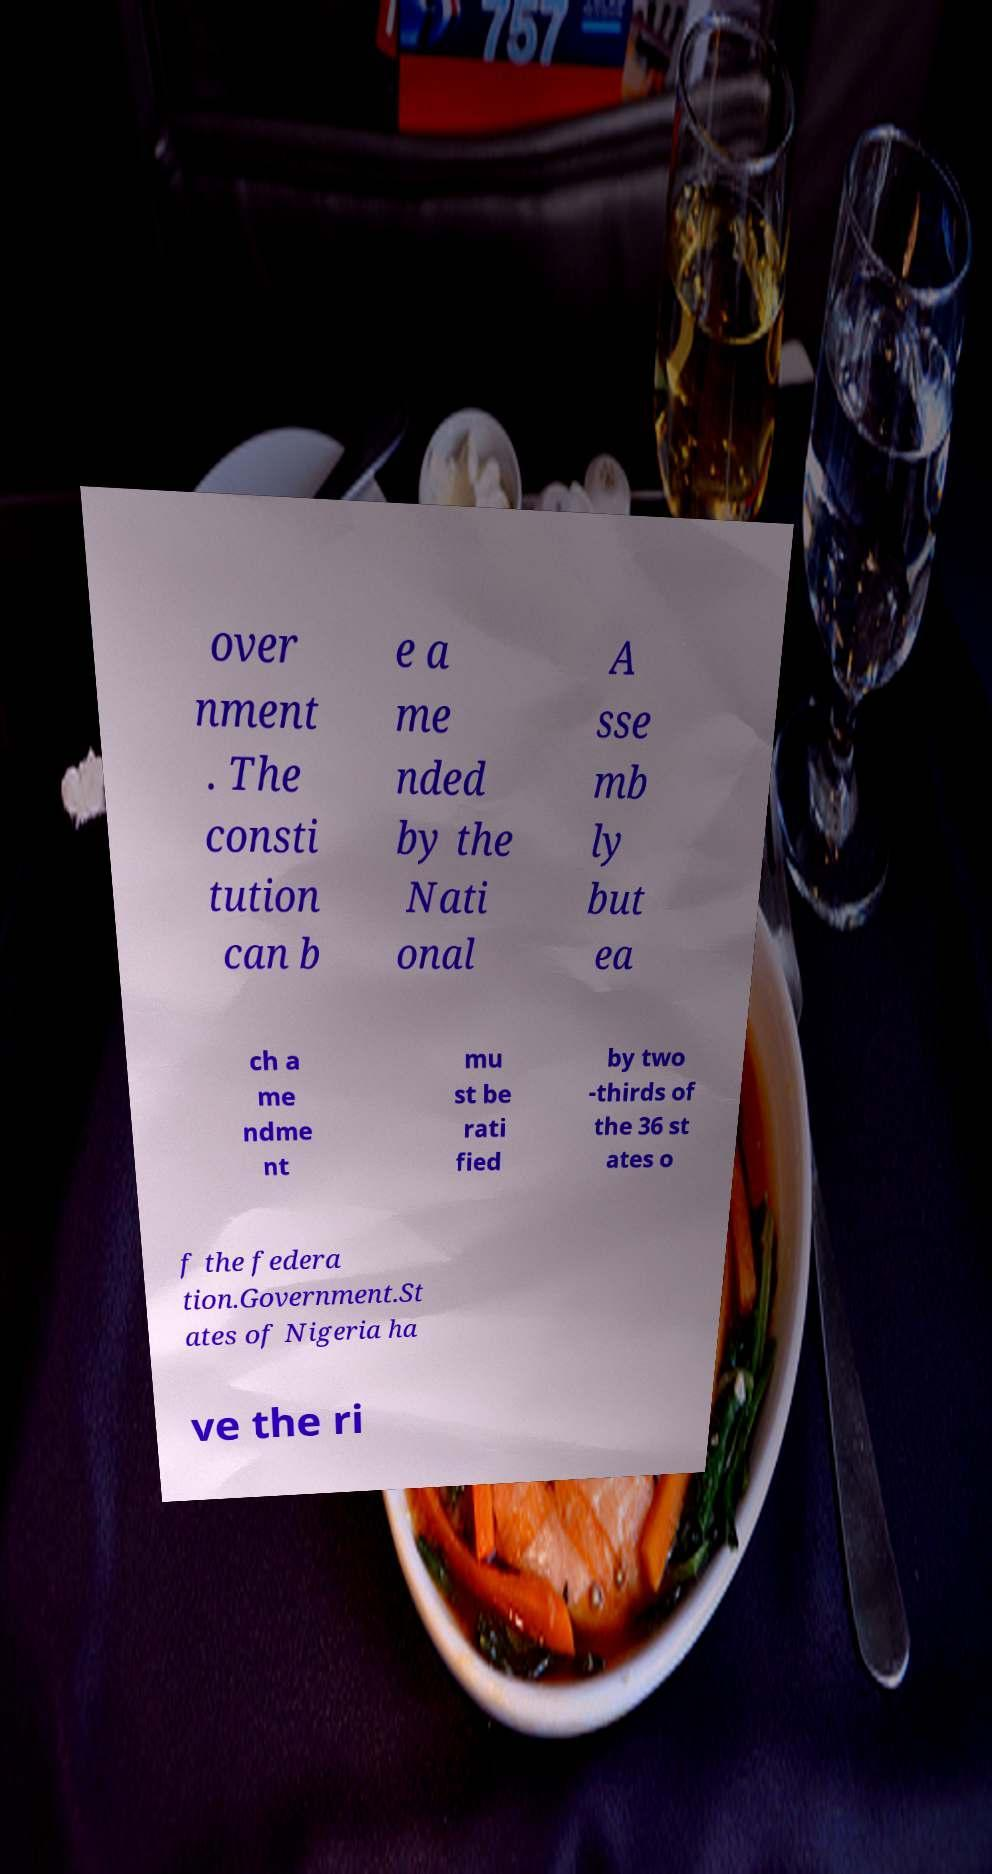I need the written content from this picture converted into text. Can you do that? over nment . The consti tution can b e a me nded by the Nati onal A sse mb ly but ea ch a me ndme nt mu st be rati fied by two -thirds of the 36 st ates o f the federa tion.Government.St ates of Nigeria ha ve the ri 